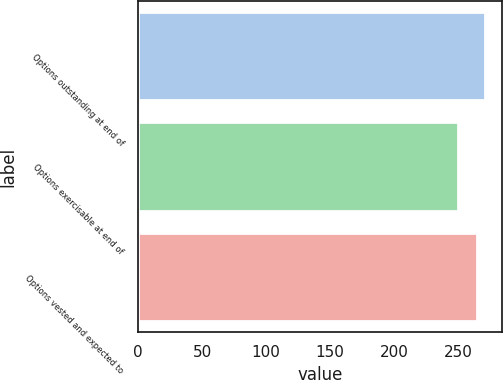<chart> <loc_0><loc_0><loc_500><loc_500><bar_chart><fcel>Options outstanding at end of<fcel>Options exercisable at end of<fcel>Options vested and expected to<nl><fcel>271<fcel>250<fcel>265<nl></chart> 